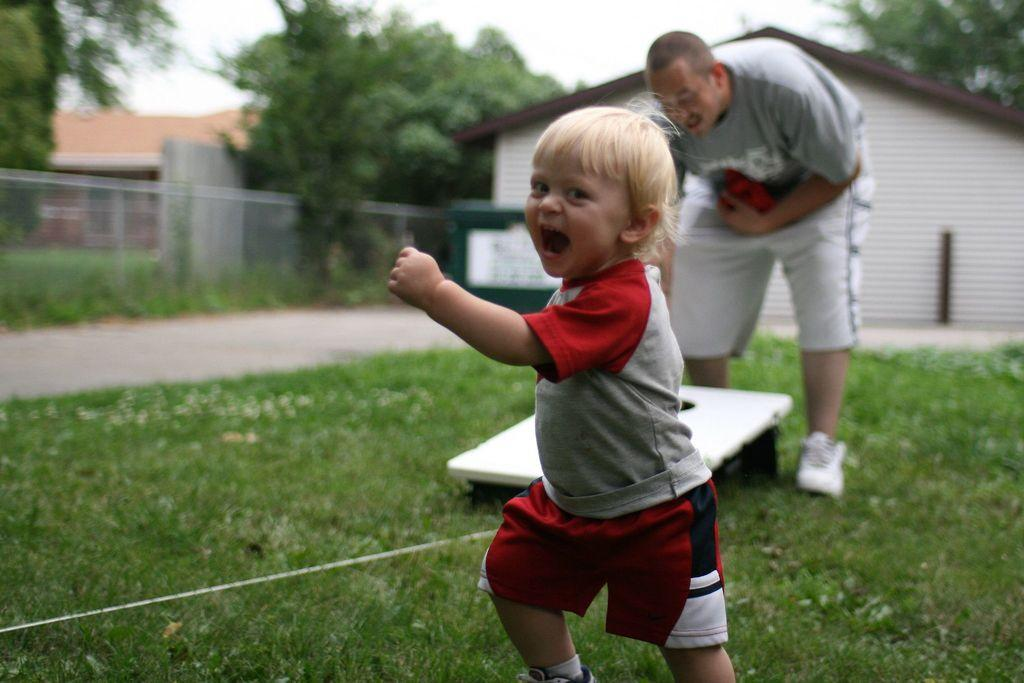What is the boy in the image doing? The boy is walking in the image. What is the man in the image doing? The man is standing in the image. What can be found on the grass in the image? There is an object on the grass in the image. What is visible in the background of the image? Houses, trees, and a fence are visible in the background of the image. What type of vegetable is being printed on the arithmetic book in the image? There is no vegetable or arithmetic book present in the image. 